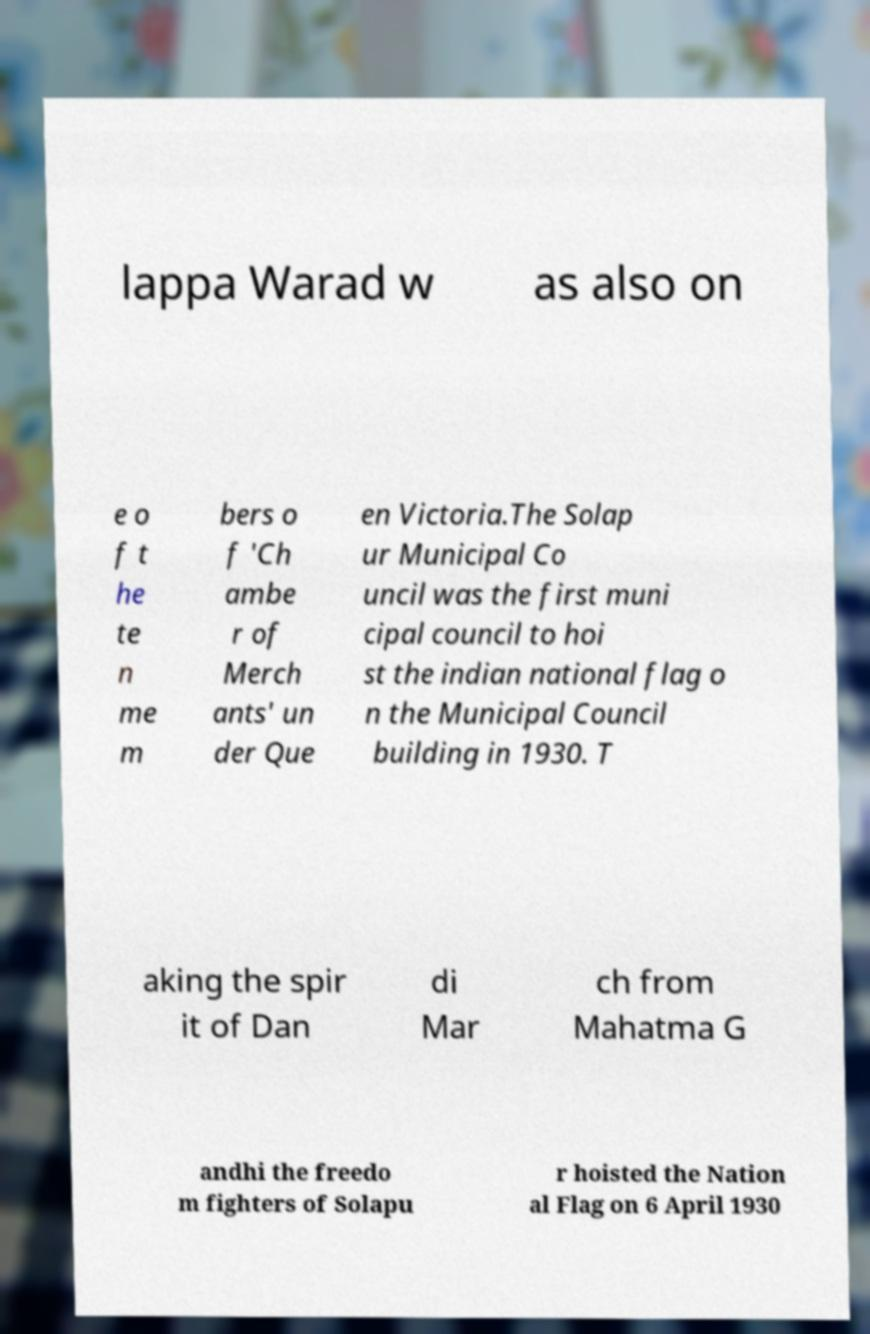Can you accurately transcribe the text from the provided image for me? lappa Warad w as also on e o f t he te n me m bers o f 'Ch ambe r of Merch ants' un der Que en Victoria.The Solap ur Municipal Co uncil was the first muni cipal council to hoi st the indian national flag o n the Municipal Council building in 1930. T aking the spir it of Dan di Mar ch from Mahatma G andhi the freedo m fighters of Solapu r hoisted the Nation al Flag on 6 April 1930 